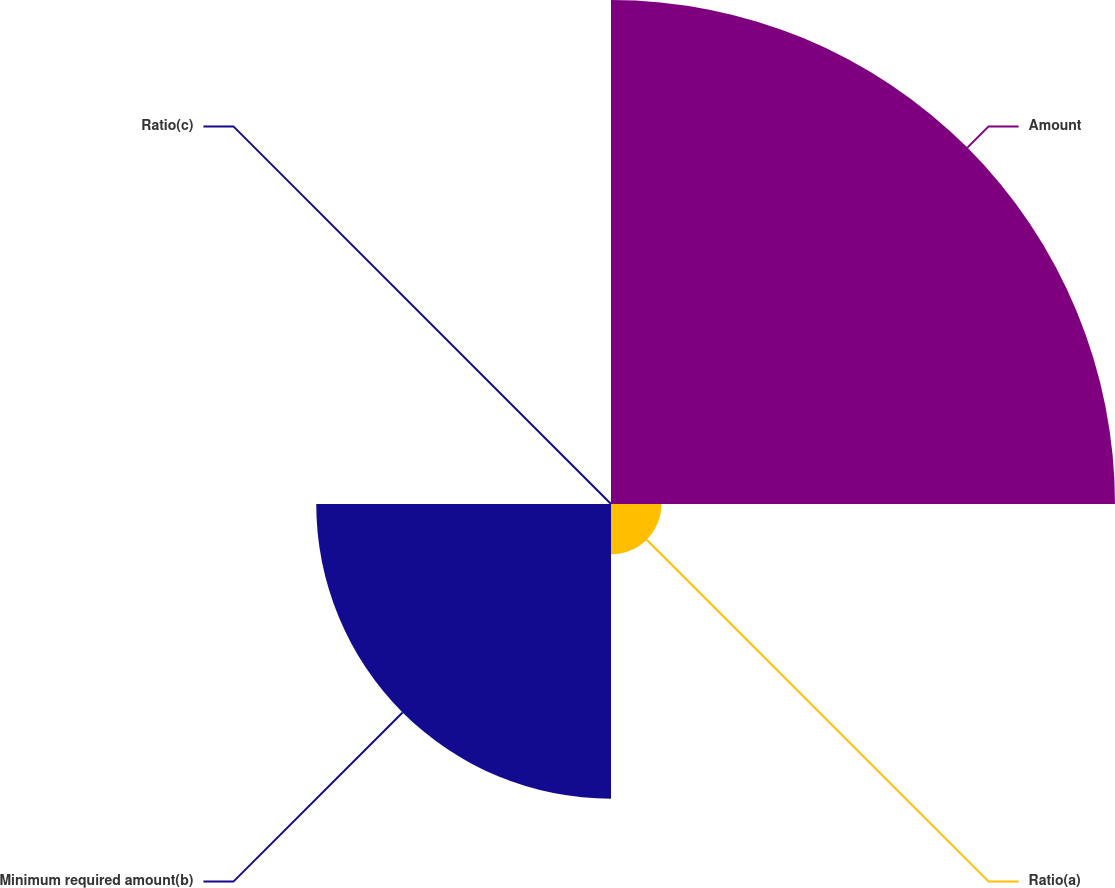<chart> <loc_0><loc_0><loc_500><loc_500><pie_chart><fcel>Amount<fcel>Ratio(a)<fcel>Minimum required amount(b)<fcel>Ratio(c)<nl><fcel>59.35%<fcel>5.94%<fcel>34.71%<fcel>0.0%<nl></chart> 